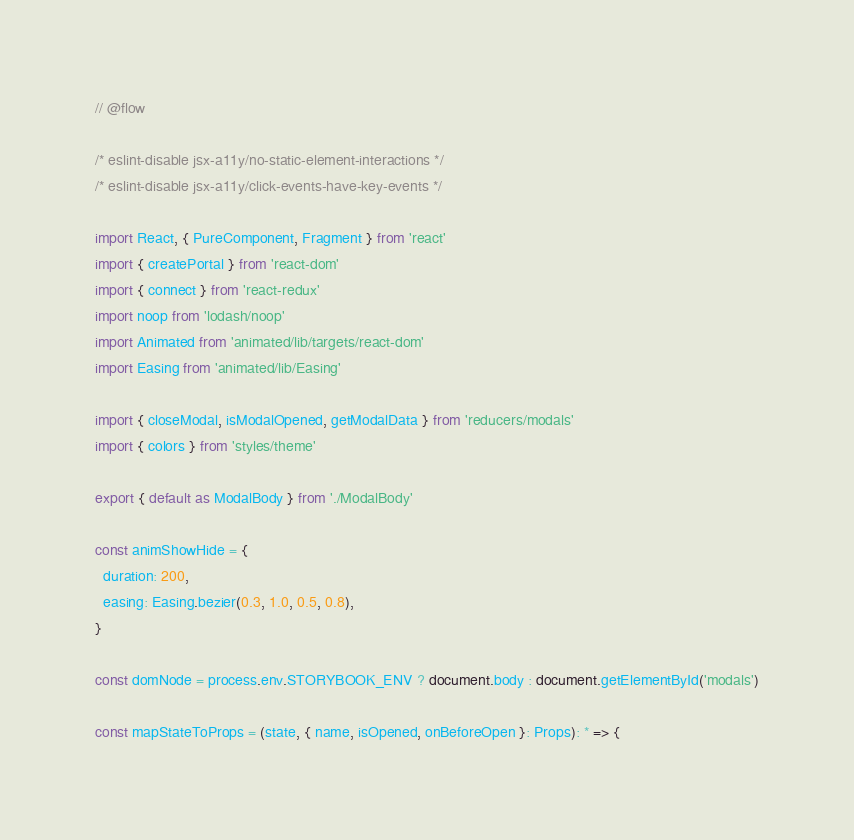<code> <loc_0><loc_0><loc_500><loc_500><_JavaScript_>// @flow

/* eslint-disable jsx-a11y/no-static-element-interactions */
/* eslint-disable jsx-a11y/click-events-have-key-events */

import React, { PureComponent, Fragment } from 'react'
import { createPortal } from 'react-dom'
import { connect } from 'react-redux'
import noop from 'lodash/noop'
import Animated from 'animated/lib/targets/react-dom'
import Easing from 'animated/lib/Easing'

import { closeModal, isModalOpened, getModalData } from 'reducers/modals'
import { colors } from 'styles/theme'

export { default as ModalBody } from './ModalBody'

const animShowHide = {
  duration: 200,
  easing: Easing.bezier(0.3, 1.0, 0.5, 0.8),
}

const domNode = process.env.STORYBOOK_ENV ? document.body : document.getElementById('modals')

const mapStateToProps = (state, { name, isOpened, onBeforeOpen }: Props): * => {</code> 